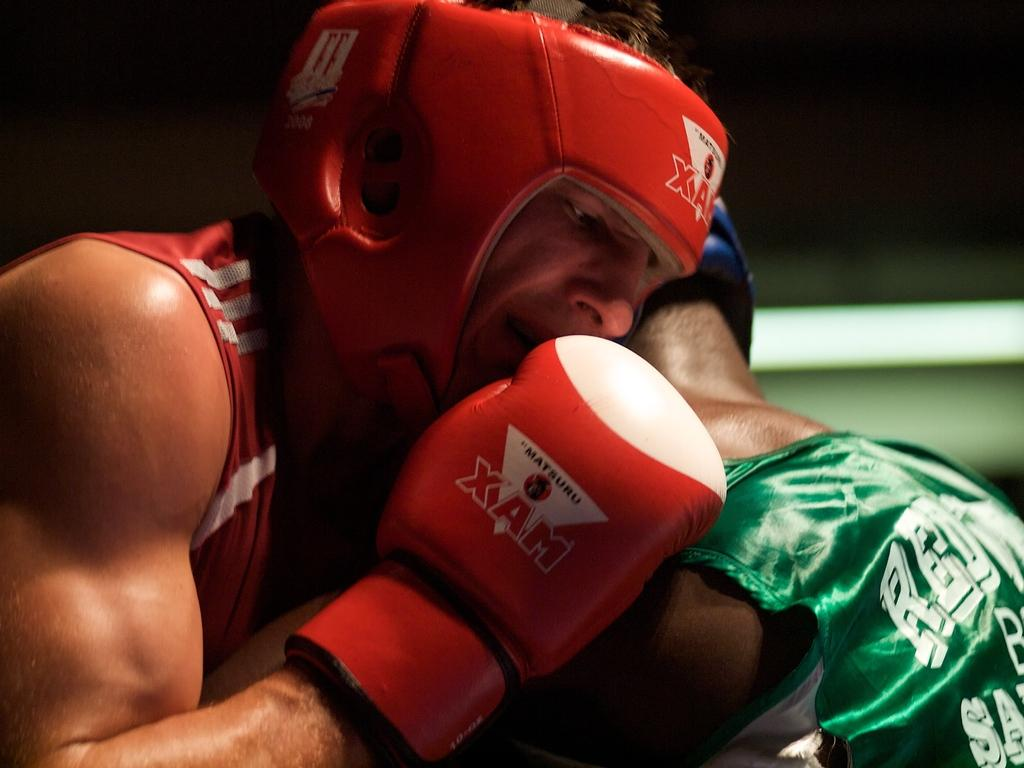Provide a one-sentence caption for the provided image. Two boxers are locked together, one sporting a glove titled "XAM.". 